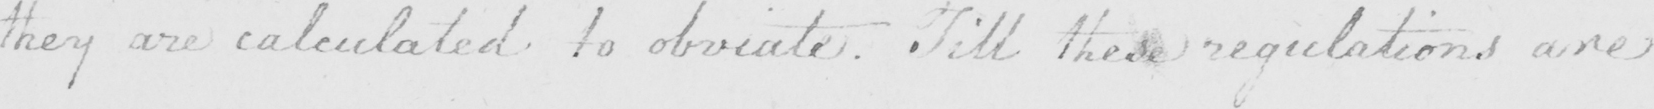What does this handwritten line say? they are calculated to obviate . Till these regulations are 